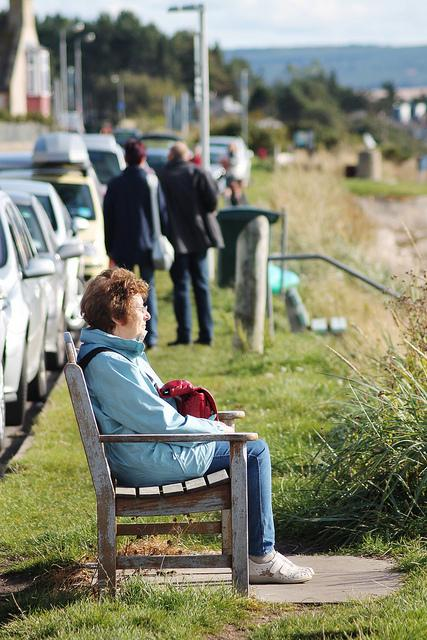How are her shoes tightened?

Choices:
A) velcro
B) buckles
C) zippers
D) laces velcro 